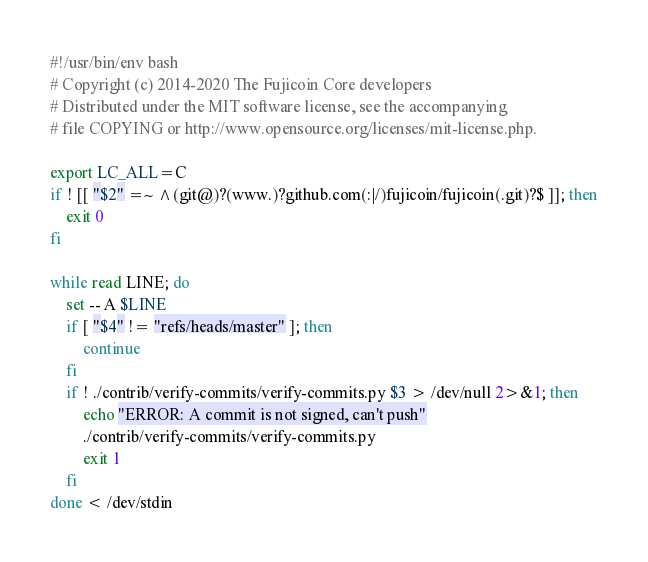<code> <loc_0><loc_0><loc_500><loc_500><_Bash_>#!/usr/bin/env bash
# Copyright (c) 2014-2020 The Fujicoin Core developers
# Distributed under the MIT software license, see the accompanying
# file COPYING or http://www.opensource.org/licenses/mit-license.php.

export LC_ALL=C
if ! [[ "$2" =~ ^(git@)?(www.)?github.com(:|/)fujicoin/fujicoin(.git)?$ ]]; then
    exit 0
fi

while read LINE; do
    set -- A $LINE
    if [ "$4" != "refs/heads/master" ]; then
        continue
    fi
    if ! ./contrib/verify-commits/verify-commits.py $3 > /dev/null 2>&1; then
        echo "ERROR: A commit is not signed, can't push"
        ./contrib/verify-commits/verify-commits.py
        exit 1
    fi
done < /dev/stdin
</code> 